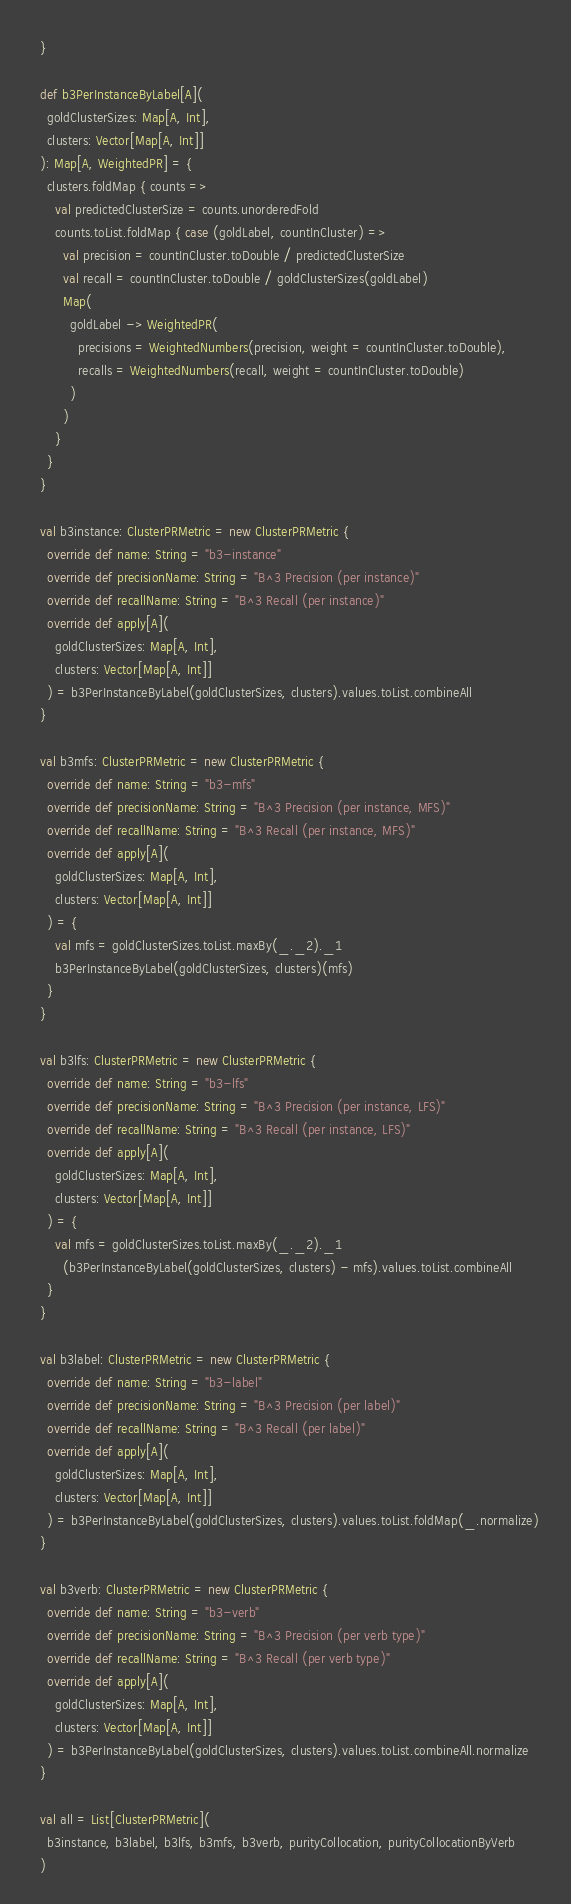<code> <loc_0><loc_0><loc_500><loc_500><_Scala_>  }

  def b3PerInstanceByLabel[A](
    goldClusterSizes: Map[A, Int],
    clusters: Vector[Map[A, Int]]
  ): Map[A, WeightedPR] = {
    clusters.foldMap { counts =>
      val predictedClusterSize = counts.unorderedFold
      counts.toList.foldMap { case (goldLabel, countInCluster) =>
        val precision = countInCluster.toDouble / predictedClusterSize
        val recall = countInCluster.toDouble / goldClusterSizes(goldLabel)
        Map(
          goldLabel -> WeightedPR(
            precisions = WeightedNumbers(precision, weight = countInCluster.toDouble),
            recalls = WeightedNumbers(recall, weight = countInCluster.toDouble)
          )
        )
      }
    }
  }

  val b3instance: ClusterPRMetric = new ClusterPRMetric {
    override def name: String = "b3-instance"
    override def precisionName: String = "B^3 Precision (per instance)"
    override def recallName: String = "B^3 Recall (per instance)"
    override def apply[A](
      goldClusterSizes: Map[A, Int],
      clusters: Vector[Map[A, Int]]
    ) = b3PerInstanceByLabel(goldClusterSizes, clusters).values.toList.combineAll
  }

  val b3mfs: ClusterPRMetric = new ClusterPRMetric {
    override def name: String = "b3-mfs"
    override def precisionName: String = "B^3 Precision (per instance, MFS)"
    override def recallName: String = "B^3 Recall (per instance, MFS)"
    override def apply[A](
      goldClusterSizes: Map[A, Int],
      clusters: Vector[Map[A, Int]]
    ) = {
      val mfs = goldClusterSizes.toList.maxBy(_._2)._1
      b3PerInstanceByLabel(goldClusterSizes, clusters)(mfs)
    }
  }

  val b3lfs: ClusterPRMetric = new ClusterPRMetric {
    override def name: String = "b3-lfs"
    override def precisionName: String = "B^3 Precision (per instance, LFS)"
    override def recallName: String = "B^3 Recall (per instance, LFS)"
    override def apply[A](
      goldClusterSizes: Map[A, Int],
      clusters: Vector[Map[A, Int]]
    ) = {
      val mfs = goldClusterSizes.toList.maxBy(_._2)._1
        (b3PerInstanceByLabel(goldClusterSizes, clusters) - mfs).values.toList.combineAll
    }
  }

  val b3label: ClusterPRMetric = new ClusterPRMetric {
    override def name: String = "b3-label"
    override def precisionName: String = "B^3 Precision (per label)"
    override def recallName: String = "B^3 Recall (per label)"
    override def apply[A](
      goldClusterSizes: Map[A, Int],
      clusters: Vector[Map[A, Int]]
    ) = b3PerInstanceByLabel(goldClusterSizes, clusters).values.toList.foldMap(_.normalize)
  }

  val b3verb: ClusterPRMetric = new ClusterPRMetric {
    override def name: String = "b3-verb"
    override def precisionName: String = "B^3 Precision (per verb type)"
    override def recallName: String = "B^3 Recall (per verb type)"
    override def apply[A](
      goldClusterSizes: Map[A, Int],
      clusters: Vector[Map[A, Int]]
    ) = b3PerInstanceByLabel(goldClusterSizes, clusters).values.toList.combineAll.normalize
  }

  val all = List[ClusterPRMetric](
    b3instance, b3label, b3lfs, b3mfs, b3verb, purityCollocation, purityCollocationByVerb
  )
</code> 